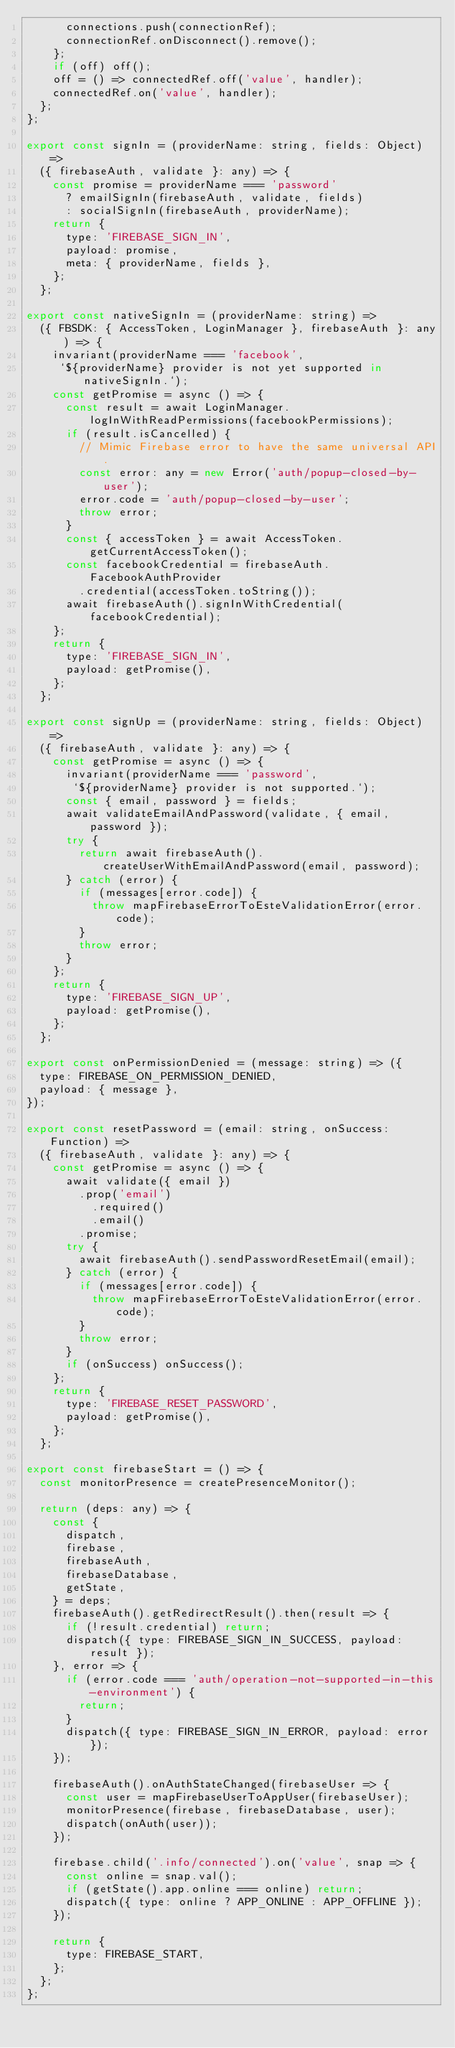<code> <loc_0><loc_0><loc_500><loc_500><_JavaScript_>      connections.push(connectionRef);
      connectionRef.onDisconnect().remove();
    };
    if (off) off();
    off = () => connectedRef.off('value', handler);
    connectedRef.on('value', handler);
  };
};

export const signIn = (providerName: string, fields: Object) =>
  ({ firebaseAuth, validate }: any) => {
    const promise = providerName === 'password'
      ? emailSignIn(firebaseAuth, validate, fields)
      : socialSignIn(firebaseAuth, providerName);
    return {
      type: 'FIREBASE_SIGN_IN',
      payload: promise,
      meta: { providerName, fields },
    };
  };

export const nativeSignIn = (providerName: string) =>
  ({ FBSDK: { AccessToken, LoginManager }, firebaseAuth }: any) => {
    invariant(providerName === 'facebook',
     `${providerName} provider is not yet supported in nativeSignIn.`);
    const getPromise = async () => {
      const result = await LoginManager.logInWithReadPermissions(facebookPermissions);
      if (result.isCancelled) {
        // Mimic Firebase error to have the same universal API.
        const error: any = new Error('auth/popup-closed-by-user');
        error.code = 'auth/popup-closed-by-user';
        throw error;
      }
      const { accessToken } = await AccessToken.getCurrentAccessToken();
      const facebookCredential = firebaseAuth.FacebookAuthProvider
        .credential(accessToken.toString());
      await firebaseAuth().signInWithCredential(facebookCredential);
    };
    return {
      type: 'FIREBASE_SIGN_IN',
      payload: getPromise(),
    };
  };

export const signUp = (providerName: string, fields: Object) =>
  ({ firebaseAuth, validate }: any) => {
    const getPromise = async () => {
      invariant(providerName === 'password',
       `${providerName} provider is not supported.`);
      const { email, password } = fields;
      await validateEmailAndPassword(validate, { email, password });
      try {
        return await firebaseAuth().createUserWithEmailAndPassword(email, password);
      } catch (error) {
        if (messages[error.code]) {
          throw mapFirebaseErrorToEsteValidationError(error.code);
        }
        throw error;
      }
    };
    return {
      type: 'FIREBASE_SIGN_UP',
      payload: getPromise(),
    };
  };

export const onPermissionDenied = (message: string) => ({
  type: FIREBASE_ON_PERMISSION_DENIED,
  payload: { message },
});

export const resetPassword = (email: string, onSuccess: Function) =>
  ({ firebaseAuth, validate }: any) => {
    const getPromise = async () => {
      await validate({ email })
        .prop('email')
          .required()
          .email()
        .promise;
      try {
        await firebaseAuth().sendPasswordResetEmail(email);
      } catch (error) {
        if (messages[error.code]) {
          throw mapFirebaseErrorToEsteValidationError(error.code);
        }
        throw error;
      }
      if (onSuccess) onSuccess();
    };
    return {
      type: 'FIREBASE_RESET_PASSWORD',
      payload: getPromise(),
    };
  };

export const firebaseStart = () => {
  const monitorPresence = createPresenceMonitor();

  return (deps: any) => {
    const {
      dispatch,
      firebase,
      firebaseAuth,
      firebaseDatabase,
      getState,
    } = deps;
    firebaseAuth().getRedirectResult().then(result => {
      if (!result.credential) return;
      dispatch({ type: FIREBASE_SIGN_IN_SUCCESS, payload: result });
    }, error => {
      if (error.code === 'auth/operation-not-supported-in-this-environment') {
        return;
      }
      dispatch({ type: FIREBASE_SIGN_IN_ERROR, payload: error });
    });

    firebaseAuth().onAuthStateChanged(firebaseUser => {
      const user = mapFirebaseUserToAppUser(firebaseUser);
      monitorPresence(firebase, firebaseDatabase, user);
      dispatch(onAuth(user));
    });

    firebase.child('.info/connected').on('value', snap => {
      const online = snap.val();
      if (getState().app.online === online) return;
      dispatch({ type: online ? APP_ONLINE : APP_OFFLINE });
    });

    return {
      type: FIREBASE_START,
    };
  };
};
</code> 